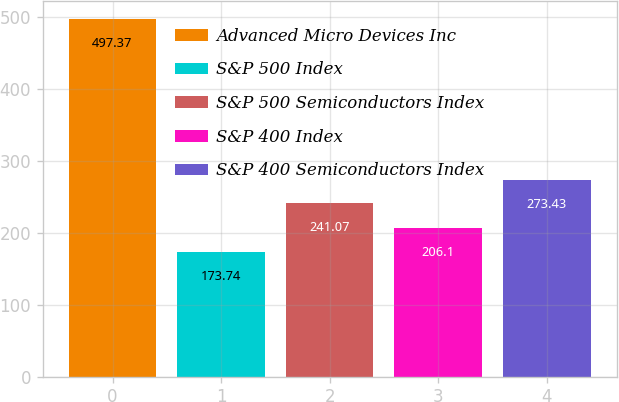Convert chart to OTSL. <chart><loc_0><loc_0><loc_500><loc_500><bar_chart><fcel>Advanced Micro Devices Inc<fcel>S&P 500 Index<fcel>S&P 500 Semiconductors Index<fcel>S&P 400 Index<fcel>S&P 400 Semiconductors Index<nl><fcel>497.37<fcel>173.74<fcel>241.07<fcel>206.1<fcel>273.43<nl></chart> 